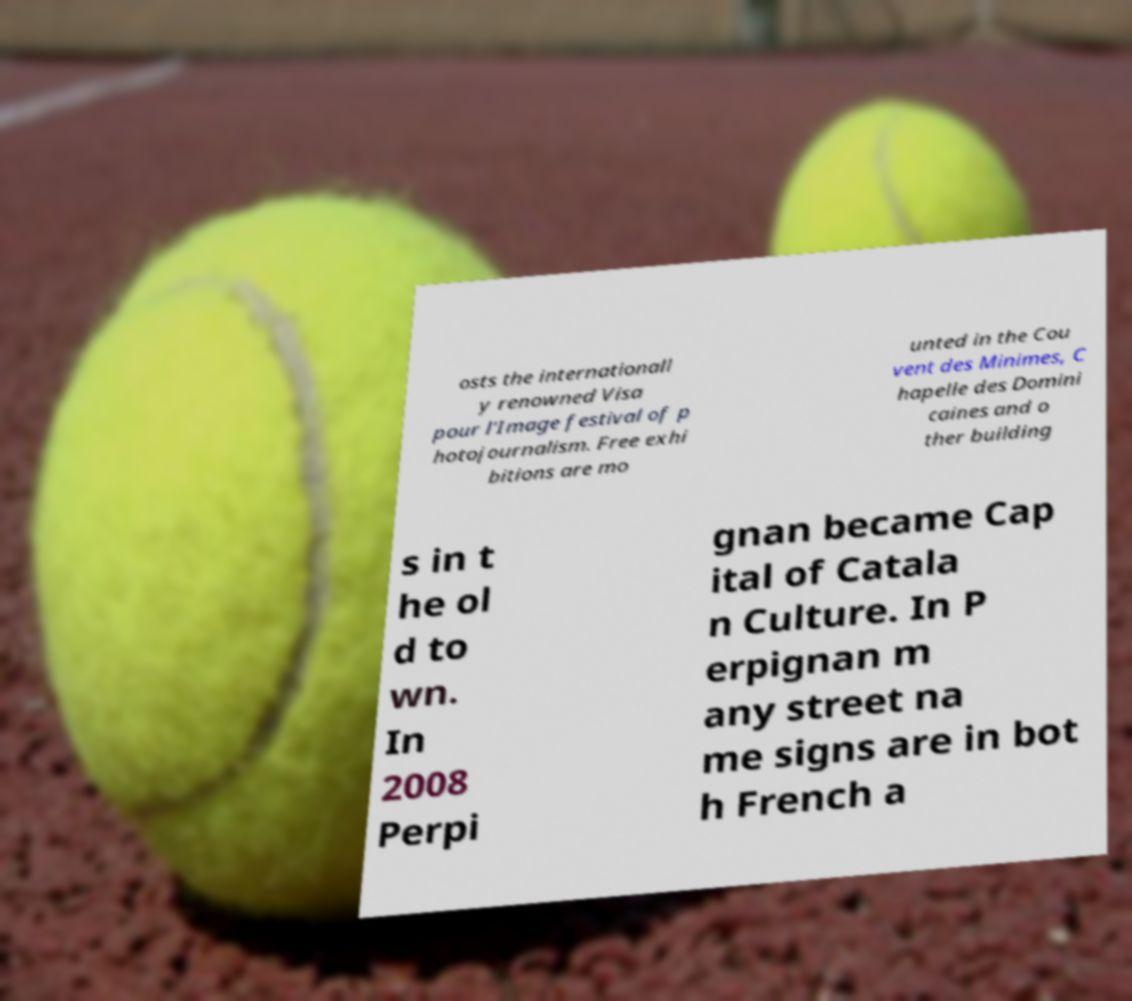What messages or text are displayed in this image? I need them in a readable, typed format. osts the internationall y renowned Visa pour l'Image festival of p hotojournalism. Free exhi bitions are mo unted in the Cou vent des Minimes, C hapelle des Domini caines and o ther building s in t he ol d to wn. In 2008 Perpi gnan became Cap ital of Catala n Culture. In P erpignan m any street na me signs are in bot h French a 